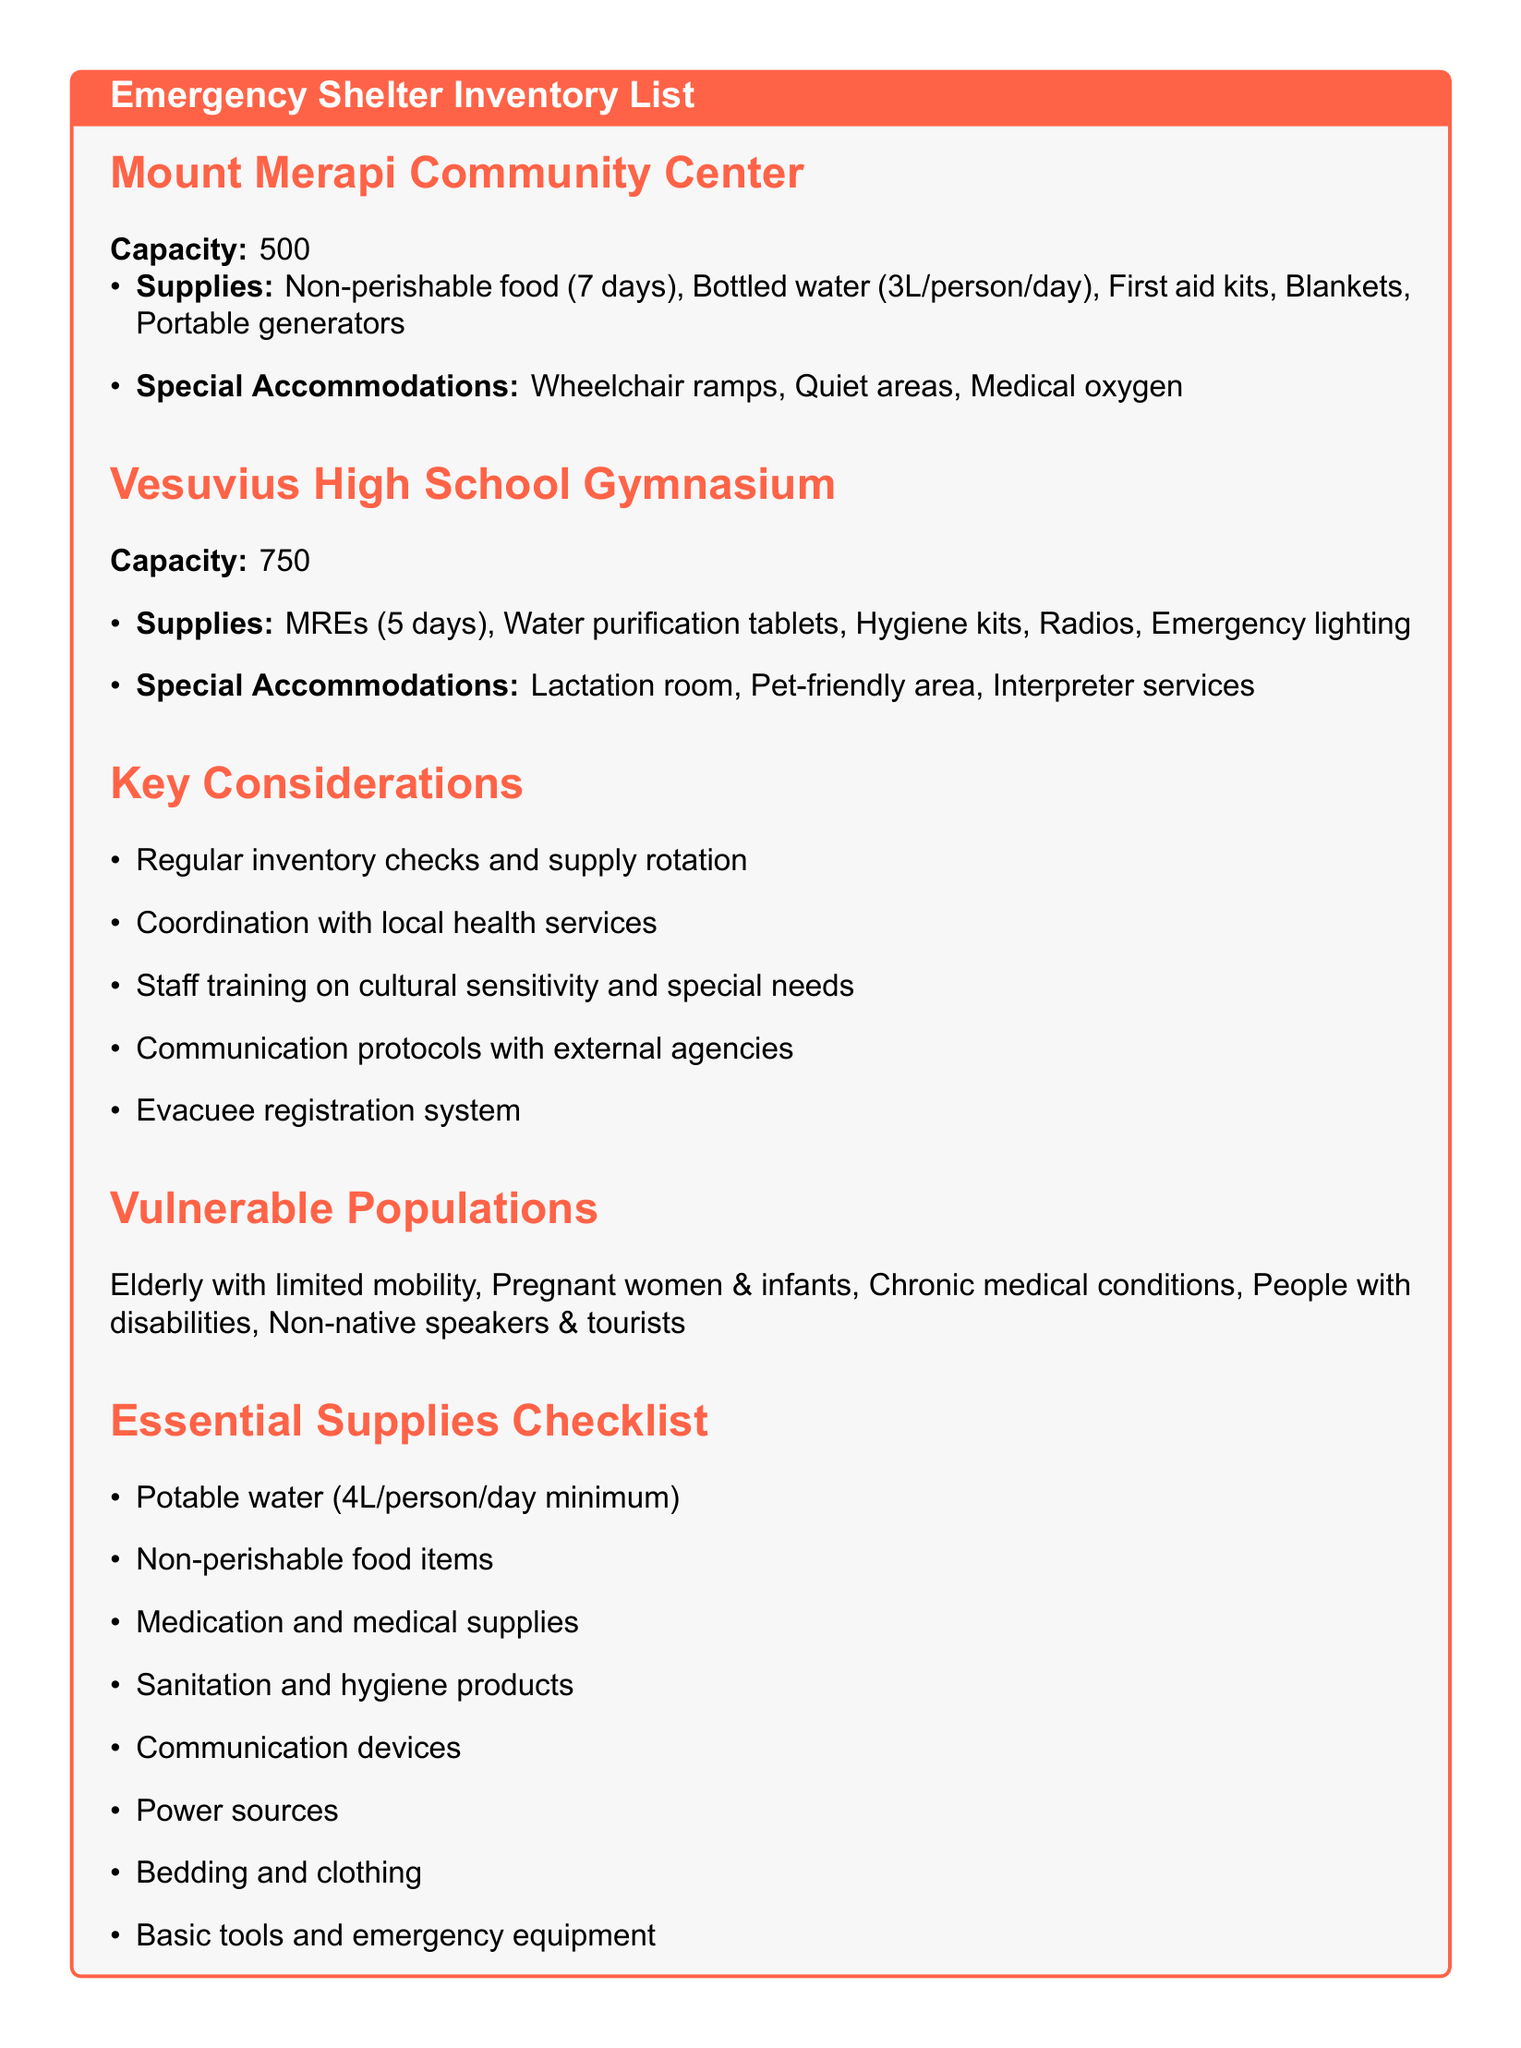What is the capacity of Mount Merapi Community Center? The capacity is listed under the shelter section for Mount Merapi Community Center.
Answer: 500 What supplies are available at Vesuvius High School Gymnasium? The supplies are detailed in the shelter section specifically for Vesuvius High School Gymnasium.
Answer: MREs for 5 days, water purification tablets, personal hygiene kits, battery-powered radios, emergency lighting What special accommodations are provided at Mount Merapi Community Center? The special accommodations are specified in the shelter section for Mount Merapi Community Center.
Answer: Wheelchair accessible ramps, designated quiet areas for sensory-sensitive individuals, medical oxygen supplies How many key considerations are listed in the document? The number of key considerations can be counted from the relevant section.
Answer: 5 Which vulnerable population requires interpreter services? The document specifies which vulnerable populations may need special accommodations in terms of communication.
Answer: Non-native speakers and tourists What is the minimum potable water supply per person per day? The minimum requirement for potable water is included in the essential supplies checklist.
Answer: 4 liters Does Vesuvius High School Gymnasium have a lactation room? The presence of a lactation room is noted in the special accommodations for Vesuvius High School Gymnasium.
Answer: Yes What type of food is listed for the supplies at Mount Merapi Community Center? The type of food mentioned is found in the supplies section for Mount Merapi Community Center.
Answer: Non-perishable food for 7 days 